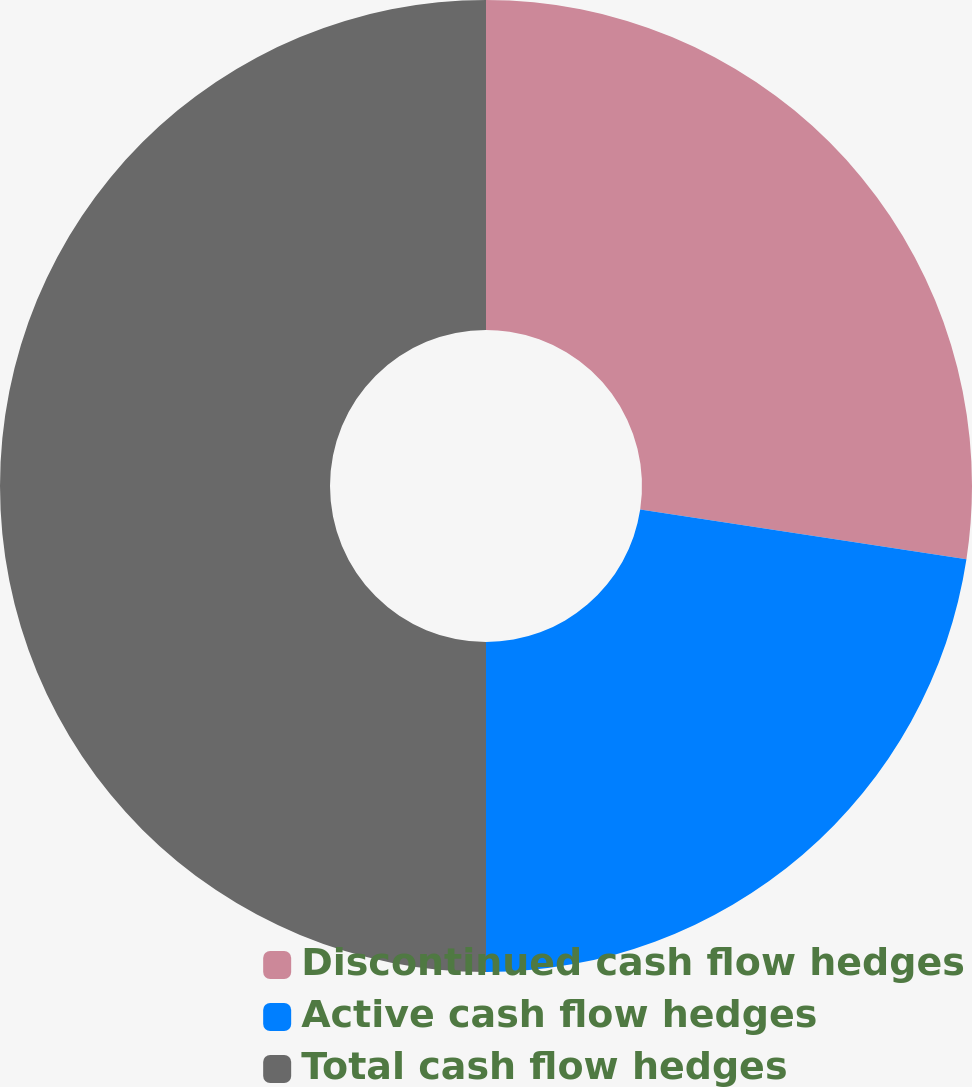Convert chart. <chart><loc_0><loc_0><loc_500><loc_500><pie_chart><fcel>Discontinued cash flow hedges<fcel>Active cash flow hedges<fcel>Total cash flow hedges<nl><fcel>27.41%<fcel>22.59%<fcel>50.0%<nl></chart> 